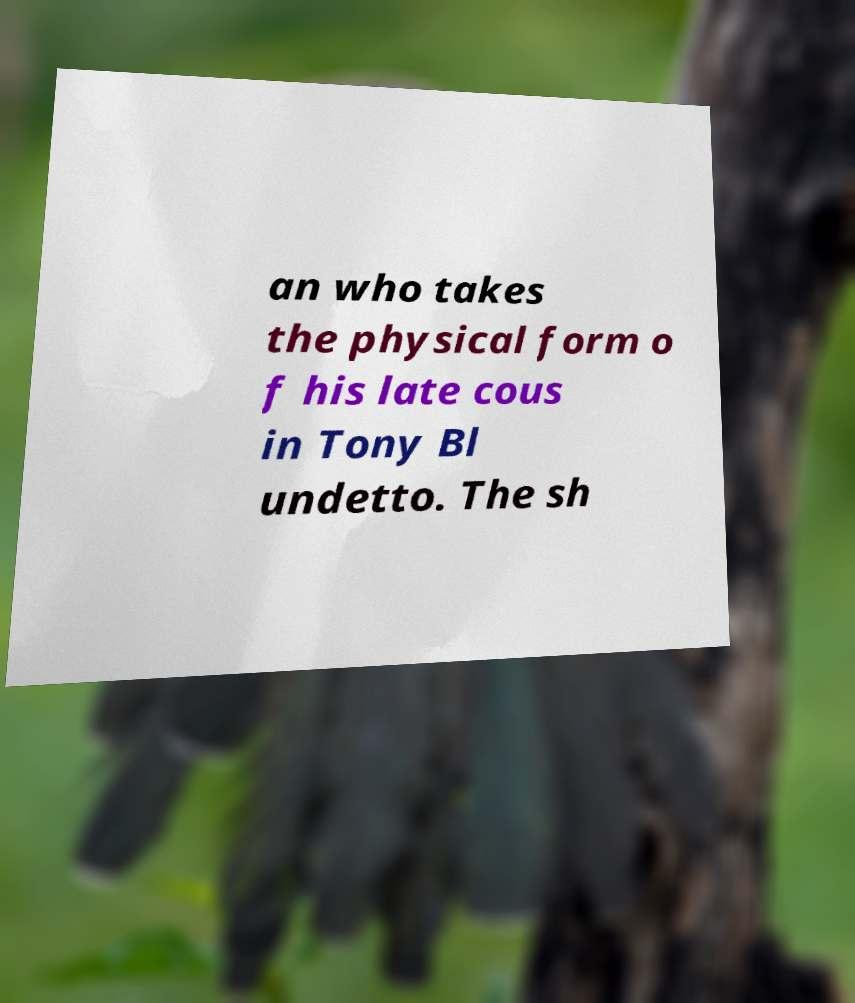What messages or text are displayed in this image? I need them in a readable, typed format. an who takes the physical form o f his late cous in Tony Bl undetto. The sh 